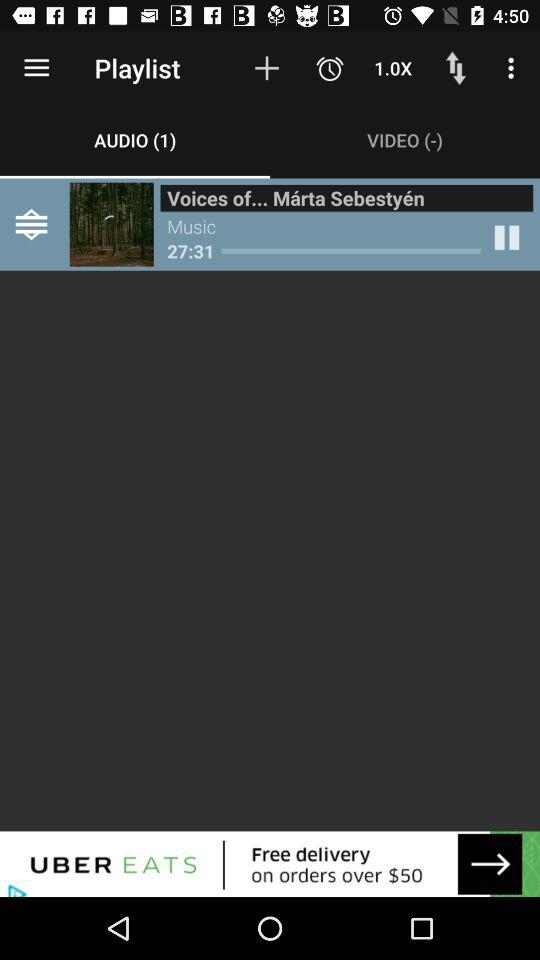How many total results are there? There are 50 results. 